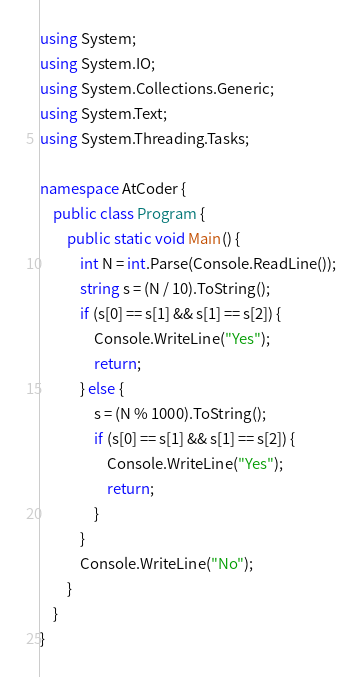Convert code to text. <code><loc_0><loc_0><loc_500><loc_500><_C#_>using System;
using System.IO;
using System.Collections.Generic;
using System.Text;
using System.Threading.Tasks;

namespace AtCoder {
    public class Program {
        public static void Main() {
            int N = int.Parse(Console.ReadLine());
            string s = (N / 10).ToString();
            if (s[0] == s[1] && s[1] == s[2]) {
                Console.WriteLine("Yes");
                return;
            } else {
                s = (N % 1000).ToString();
                if (s[0] == s[1] && s[1] == s[2]) {
                    Console.WriteLine("Yes");
                    return;
                }
            }
            Console.WriteLine("No");
        }
    }
}
</code> 